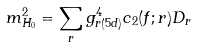<formula> <loc_0><loc_0><loc_500><loc_500>m _ { H _ { 0 } } ^ { 2 } = \sum _ { r } g _ { r ( 5 d ) } ^ { 4 } c _ { 2 } ( f ; r ) D _ { r }</formula> 